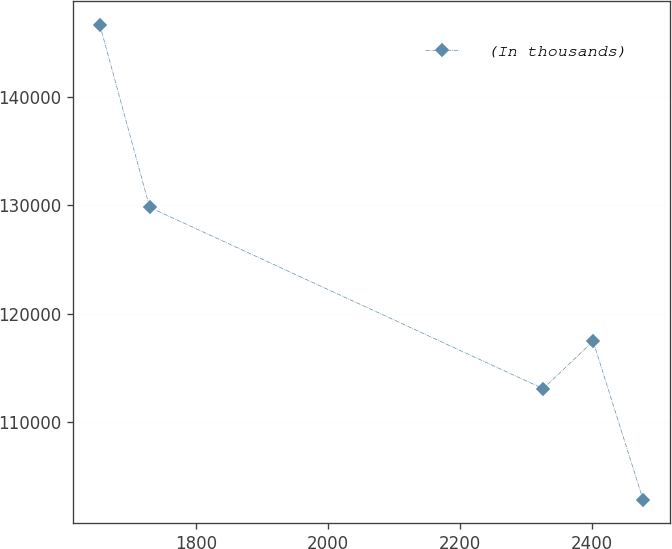Convert chart. <chart><loc_0><loc_0><loc_500><loc_500><line_chart><ecel><fcel>(In thousands)<nl><fcel>1654.36<fcel>146719<nl><fcel>1729.98<fcel>129823<nl><fcel>2325.95<fcel>113057<nl><fcel>2401.57<fcel>117448<nl><fcel>2477.19<fcel>102807<nl></chart> 